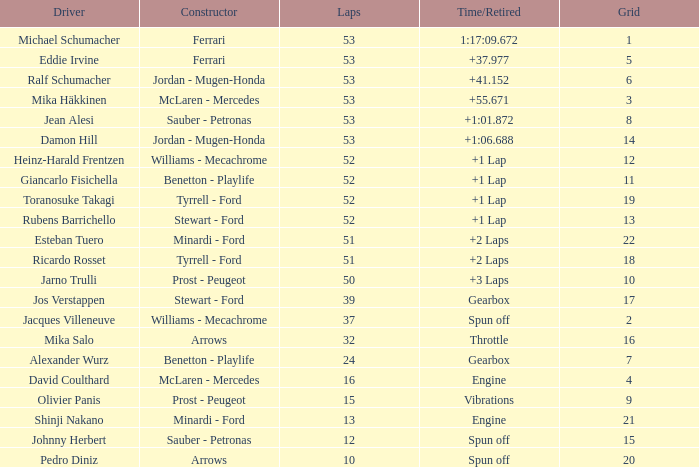Who assembled the car that managed 53 laps with a time/retired of 1:17:0 Ferrari. 